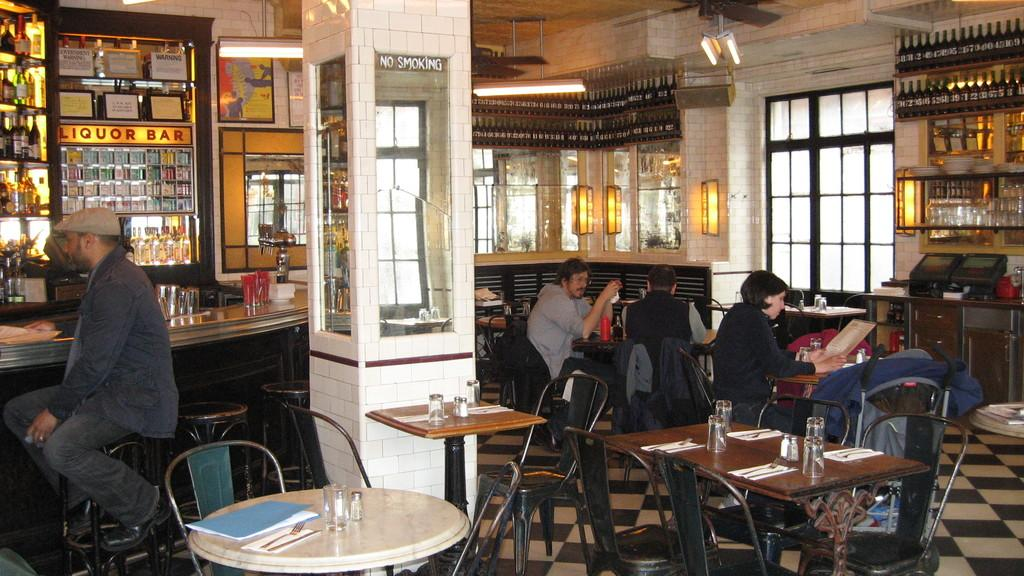What type of establishment is depicted in the image? The image is an inner view of a bar. What are the people in the image doing? There are people seated on chairs in the image. What is the main feature of the bar? There is a bar counter in the image. What type of bar is it? The text "liquor bar" is written in the image. How does the vessel turn in the image? There is no vessel present in the image, so it cannot turn. 